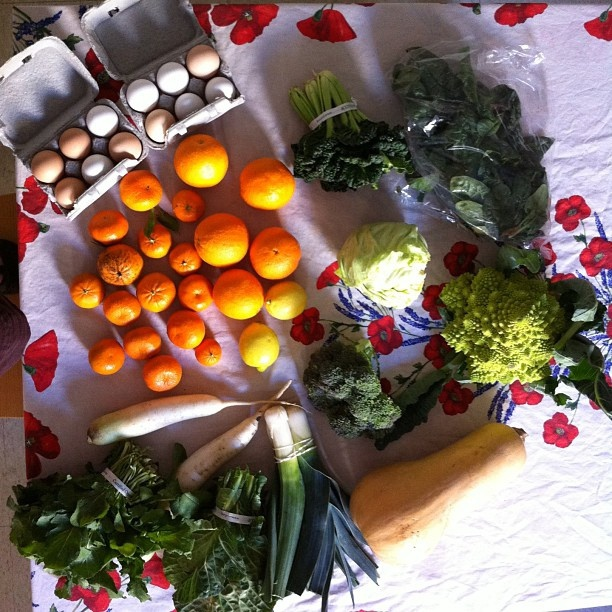Describe the objects in this image and their specific colors. I can see orange in maroon, red, brown, and orange tones, broccoli in maroon, black, darkgreen, khaki, and olive tones, broccoli in maroon, black, darkgreen, and gray tones, broccoli in maroon, black, gray, and darkgreen tones, and orange in maroon, brown, red, orange, and gold tones in this image. 